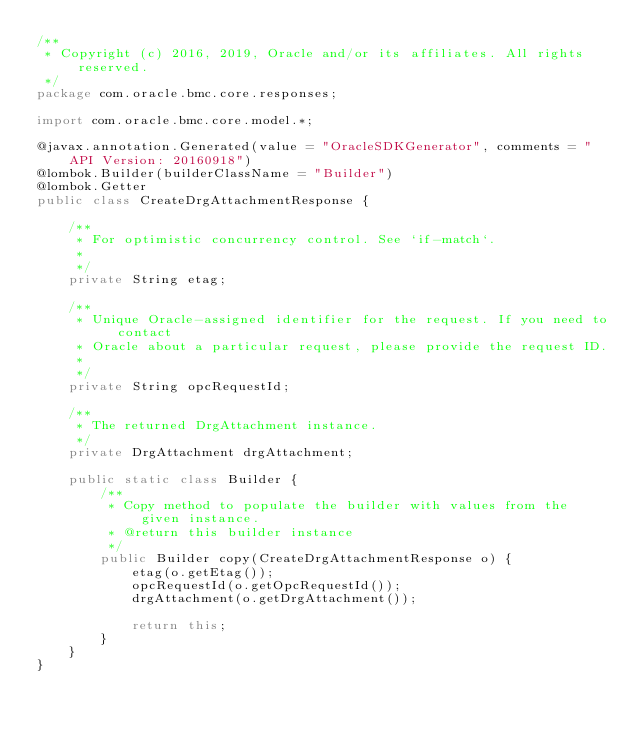<code> <loc_0><loc_0><loc_500><loc_500><_Java_>/**
 * Copyright (c) 2016, 2019, Oracle and/or its affiliates. All rights reserved.
 */
package com.oracle.bmc.core.responses;

import com.oracle.bmc.core.model.*;

@javax.annotation.Generated(value = "OracleSDKGenerator", comments = "API Version: 20160918")
@lombok.Builder(builderClassName = "Builder")
@lombok.Getter
public class CreateDrgAttachmentResponse {

    /**
     * For optimistic concurrency control. See `if-match`.
     *
     */
    private String etag;

    /**
     * Unique Oracle-assigned identifier for the request. If you need to contact
     * Oracle about a particular request, please provide the request ID.
     *
     */
    private String opcRequestId;

    /**
     * The returned DrgAttachment instance.
     */
    private DrgAttachment drgAttachment;

    public static class Builder {
        /**
         * Copy method to populate the builder with values from the given instance.
         * @return this builder instance
         */
        public Builder copy(CreateDrgAttachmentResponse o) {
            etag(o.getEtag());
            opcRequestId(o.getOpcRequestId());
            drgAttachment(o.getDrgAttachment());

            return this;
        }
    }
}
</code> 